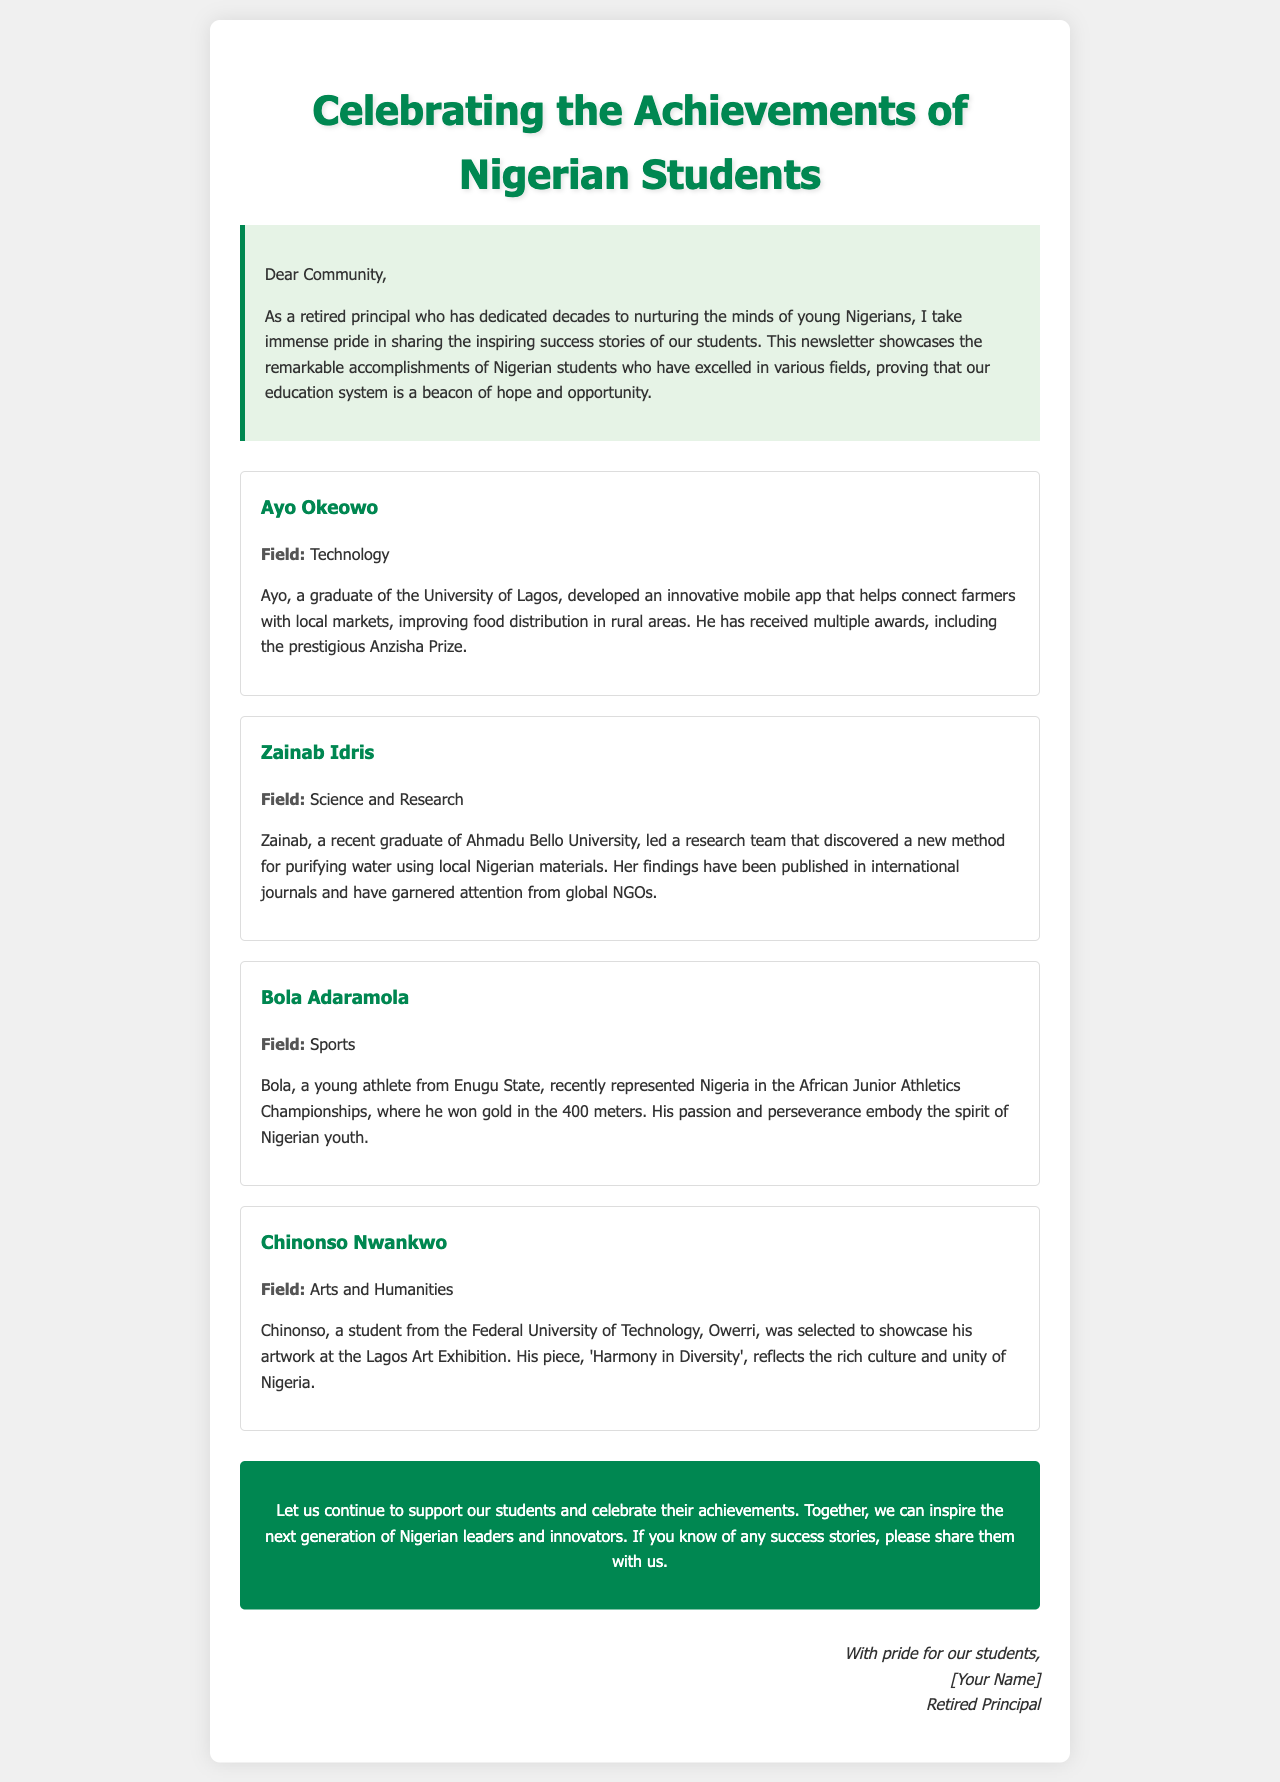What is the title of the newsletter? The title is presented prominently at the top of the document, celebrating the achievements of students.
Answer: Celebrating the Achievements of Nigerian Students Who is the first student mentioned in the newsletter? The newsletter introduces several students, with the first one being highlighted for their achievements.
Answer: Ayo Okeowo What field does Zainab Idris specialize in? The success story of Zainab Idris specifically categorizes her achievements under a particular discipline.
Answer: Science and Research What award did Ayo Okeowo receive? The document mentions a prestigious award associated with Ayo's achievements, which showcases his recognition in his field.
Answer: Anzisha Prize How many meters did Bola Adaramola win gold in? The document includes a detail about Bola's performance in a specific event, indicating his success measured in meters.
Answer: 400 meters Which university did Chinonso Nwankwo attend? Chinonso's educational background is noted in the document, specifically mentioning the institution where he studied.
Answer: Federal University of Technology, Owerri What is the call to action in the newsletter? The newsletter encourages the community to engage with the successes of students, which is summarized in a particular passage.
Answer: Support our students What is the main theme of the newsletter? The focus of the newsletter is mentioned in the introduction, relating to the success of students and the education system.
Answer: Success stories of Nigerian students 